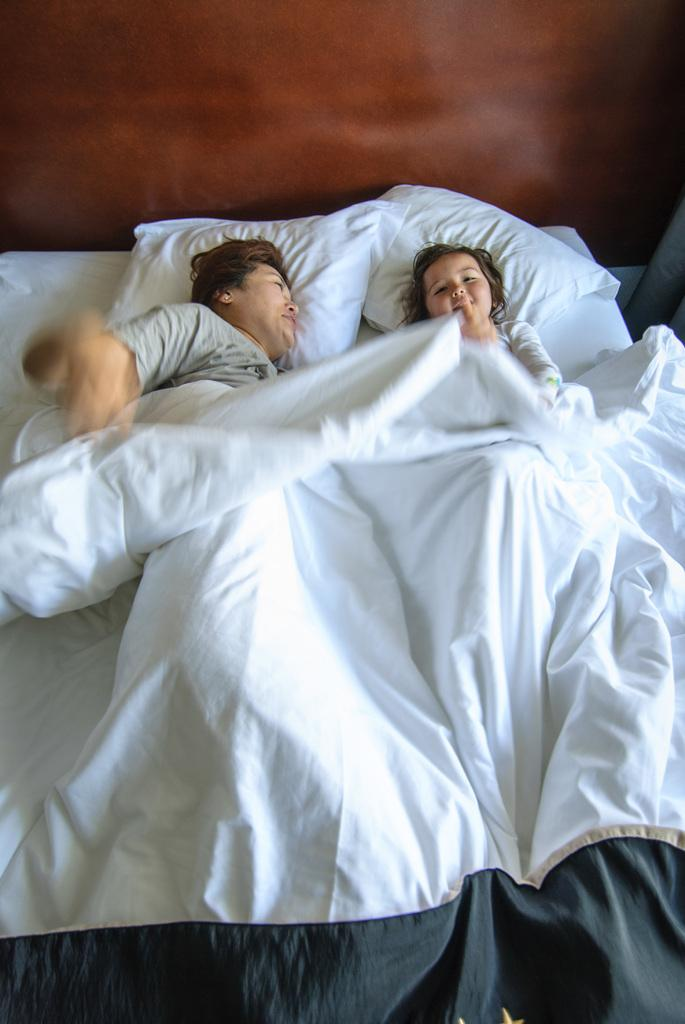How many people are in the image? There are two people in the image. Where are the two people located? The two people are on a bed. How many dogs are visible in the image? There are no dogs present in the image. What type of horn can be seen on the head of one of the people in the image? There is no horn present on the head of either person in the image. 